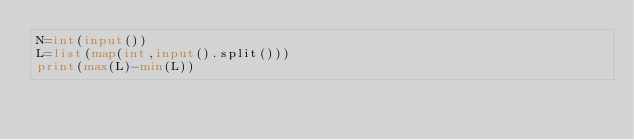Convert code to text. <code><loc_0><loc_0><loc_500><loc_500><_Python_>N=int(input())
L=list(map(int,input().split()))
print(max(L)-min(L))
</code> 